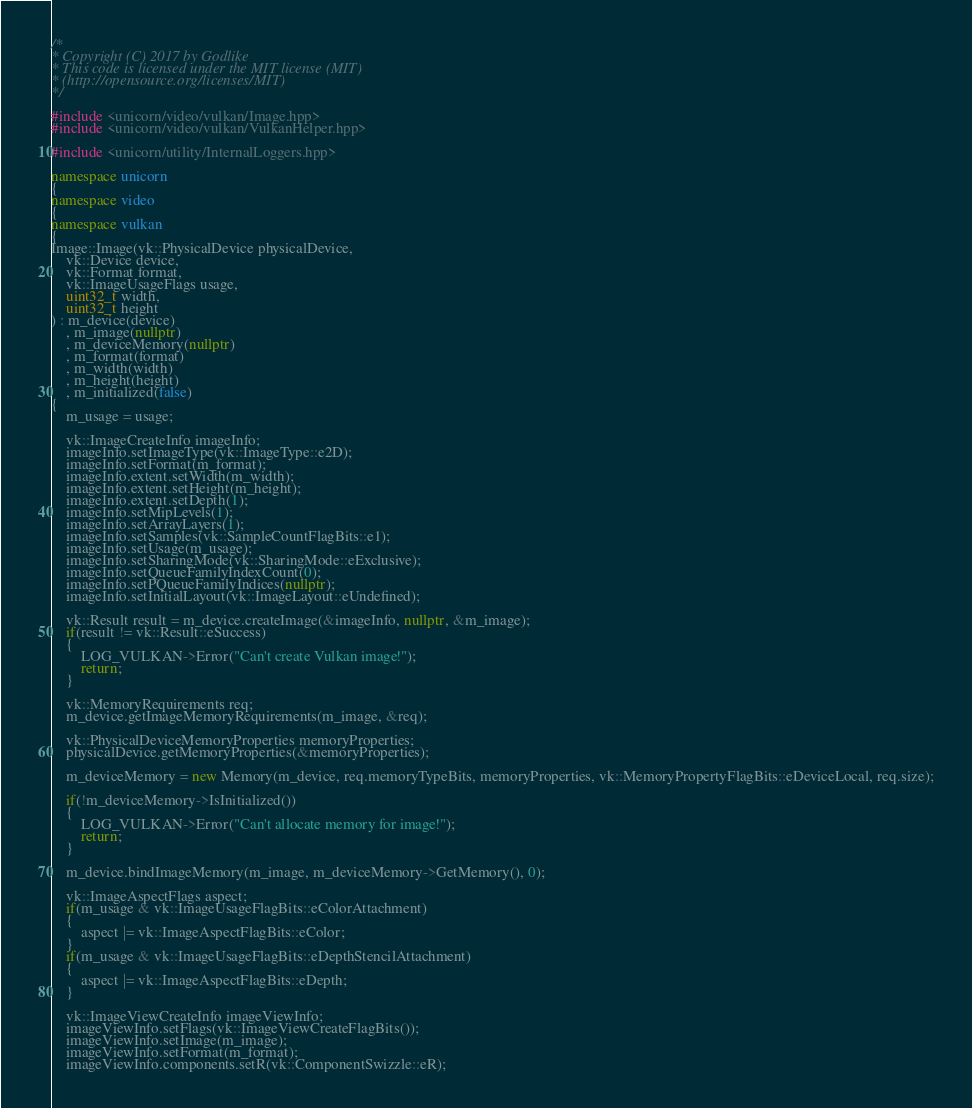Convert code to text. <code><loc_0><loc_0><loc_500><loc_500><_C++_>/*
* Copyright (C) 2017 by Godlike
* This code is licensed under the MIT license (MIT)
* (http://opensource.org/licenses/MIT)
*/

#include <unicorn/video/vulkan/Image.hpp>
#include <unicorn/video/vulkan/VulkanHelper.hpp>

#include <unicorn/utility/InternalLoggers.hpp>

namespace unicorn
{
namespace video
{
namespace vulkan
{
Image::Image(vk::PhysicalDevice physicalDevice,
    vk::Device device,
    vk::Format format,
    vk::ImageUsageFlags usage,
    uint32_t width,
    uint32_t height
) : m_device(device)
    , m_image(nullptr)
    , m_deviceMemory(nullptr)
    , m_format(format)
    , m_width(width)
    , m_height(height)
    , m_initialized(false)
{
    m_usage = usage;

    vk::ImageCreateInfo imageInfo;
    imageInfo.setImageType(vk::ImageType::e2D);
    imageInfo.setFormat(m_format);
    imageInfo.extent.setWidth(m_width);
    imageInfo.extent.setHeight(m_height);
    imageInfo.extent.setDepth(1);
    imageInfo.setMipLevels(1);
    imageInfo.setArrayLayers(1);
    imageInfo.setSamples(vk::SampleCountFlagBits::e1);
    imageInfo.setUsage(m_usage);
    imageInfo.setSharingMode(vk::SharingMode::eExclusive);
    imageInfo.setQueueFamilyIndexCount(0);
    imageInfo.setPQueueFamilyIndices(nullptr);
    imageInfo.setInitialLayout(vk::ImageLayout::eUndefined);

    vk::Result result = m_device.createImage(&imageInfo, nullptr, &m_image);
    if(result != vk::Result::eSuccess)
    {
        LOG_VULKAN->Error("Can't create Vulkan image!");
        return;
    }

    vk::MemoryRequirements req;
    m_device.getImageMemoryRequirements(m_image, &req);

    vk::PhysicalDeviceMemoryProperties memoryProperties;
    physicalDevice.getMemoryProperties(&memoryProperties);

    m_deviceMemory = new Memory(m_device, req.memoryTypeBits, memoryProperties, vk::MemoryPropertyFlagBits::eDeviceLocal, req.size);

    if(!m_deviceMemory->IsInitialized())
    {
        LOG_VULKAN->Error("Can't allocate memory for image!");
        return;
    }

    m_device.bindImageMemory(m_image, m_deviceMemory->GetMemory(), 0);

    vk::ImageAspectFlags aspect;
    if(m_usage & vk::ImageUsageFlagBits::eColorAttachment)
    {
        aspect |= vk::ImageAspectFlagBits::eColor;
    }
    if(m_usage & vk::ImageUsageFlagBits::eDepthStencilAttachment)
    {
        aspect |= vk::ImageAspectFlagBits::eDepth;
    }

    vk::ImageViewCreateInfo imageViewInfo;
    imageViewInfo.setFlags(vk::ImageViewCreateFlagBits());
    imageViewInfo.setImage(m_image);
    imageViewInfo.setFormat(m_format);
    imageViewInfo.components.setR(vk::ComponentSwizzle::eR);</code> 